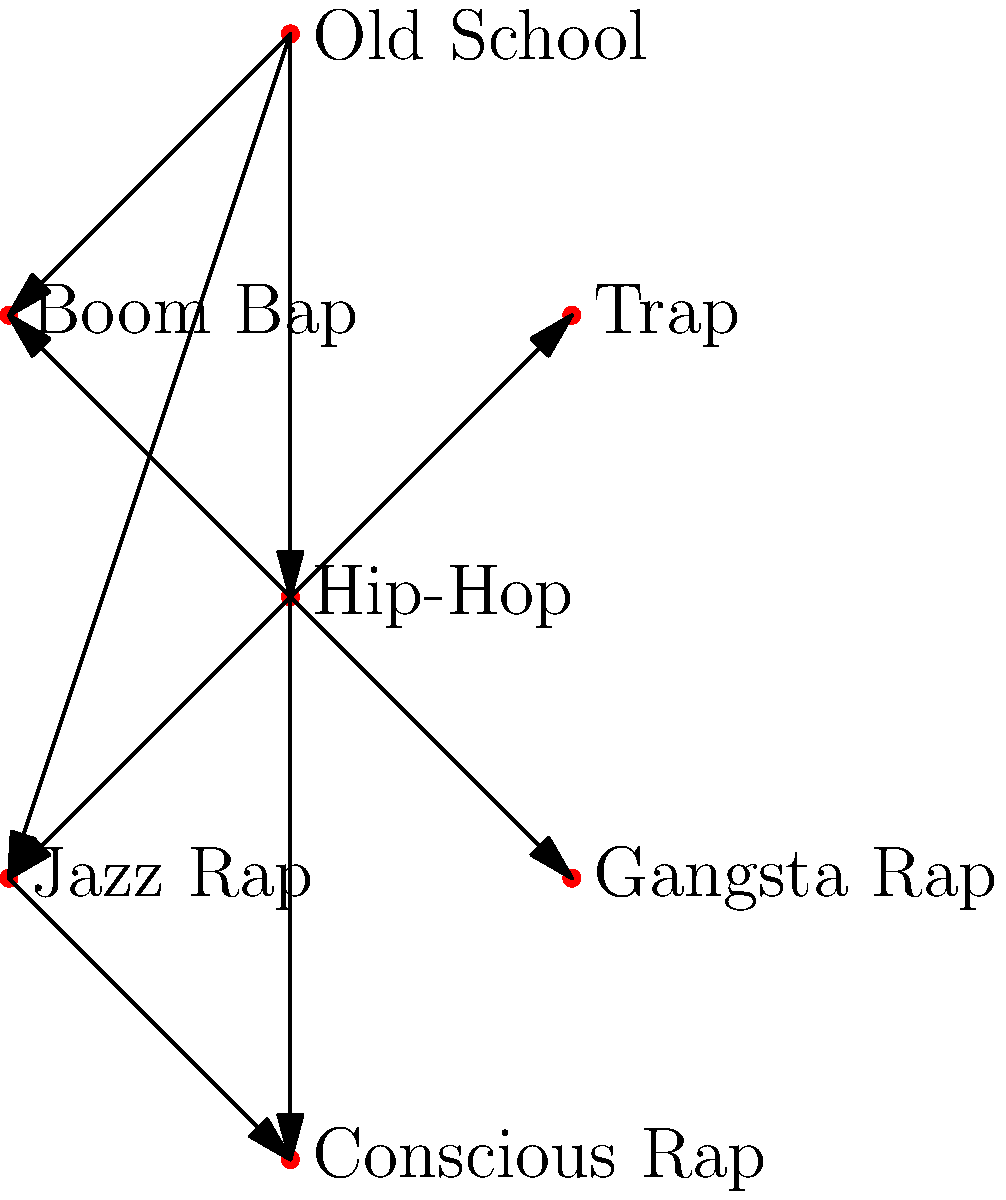In the graph representing hip-hop subgenres and their influences, what is the in-degree of the "Hip-Hop" vertex, and what does this suggest about its role in the genre's evolution? To answer this question, let's follow these steps:

1. Understand the concept of in-degree:
   The in-degree of a vertex in a directed graph is the number of edges pointing towards that vertex.

2. Identify the "Hip-Hop" vertex:
   In the graph, the "Hip-Hop" vertex is at the center (0,0).

3. Count the incoming edges to the "Hip-Hop" vertex:
   - There is one edge coming from "Old School"
   - There are no other edges pointing towards "Hip-Hop"

4. Calculate the in-degree:
   The in-degree of the "Hip-Hop" vertex is 1.

5. Interpret the meaning:
   - An in-degree of 1 suggests that Hip-Hop, as represented in this graph, has one direct predecessor or influencer: Old School.
   - This low in-degree, combined with the high out-degree (many arrows pointing out from Hip-Hop), suggests that Hip-Hop acts as a central hub or foundation from which other subgenres have evolved.
   - It implies that Hip-Hop, while influenced by Old School, has been instrumental in spawning and influencing multiple subgenres.

This structure reflects the historical development of hip-hop, where the original or "old school" style gave rise to the broader hip-hop genre, which then diversified into various subgenres over time.
Answer: In-degree: 1; Suggests Hip-Hop as a central, influential genre derived from Old School, spawning multiple subgenres. 